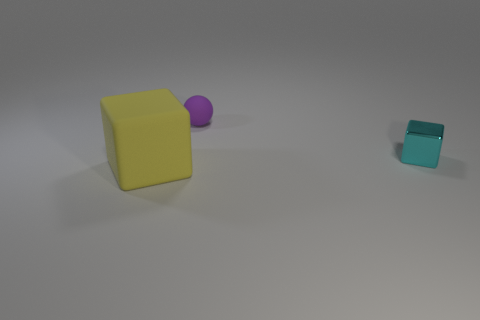Subtract all cyan cubes. How many cubes are left? 1 Subtract 1 balls. How many balls are left? 0 Add 3 cyan metallic blocks. How many objects exist? 6 Subtract all balls. How many objects are left? 2 Subtract all brown blocks. Subtract all blue balls. How many blocks are left? 2 Subtract all blue spheres. How many yellow cubes are left? 1 Subtract all small cyan blocks. Subtract all cyan objects. How many objects are left? 1 Add 3 matte blocks. How many matte blocks are left? 4 Add 3 tiny gray metallic balls. How many tiny gray metallic balls exist? 3 Subtract 0 yellow spheres. How many objects are left? 3 